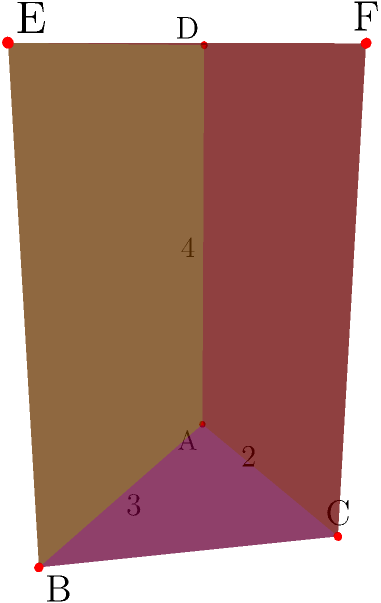As part of your daily brain exercise routine to maintain cognitive function, you're presented with a geometry challenge. Calculate the total surface area of a triangular prism with a base triangle measuring 3 units in width and 2 units in height, and a prism height of 4 units. How can you break down this problem to make it more manageable? Let's approach this step-by-step:

1) The surface area of a triangular prism consists of two triangular bases and three rectangular faces.

2) For the triangular bases:
   - Area of one triangle = $\frac{1}{2} \times base \times height$
   - Area = $\frac{1}{2} \times 3 \times 2 = 3$ square units
   - There are two identical triangular bases, so total area = $2 \times 3 = 6$ square units

3) For the rectangular faces:
   a) Rectangle ABDE:
      - Area = length × width = $3 \times 4 = 12$ square units
   b) Rectangle BCFE:
      - We need to find the hypotenuse of the base triangle using the Pythagorean theorem:
      - $hypotenuse^2 = 3^2 + 2^2 = 9 + 4 = 13$
      - $hypotenuse = \sqrt{13}$
      - Area = $\sqrt{13} \times 4 = 4\sqrt{13}$ square units
   c) Rectangle ACFD:
      - Area = $2 \times 4 = 8$ square units

4) Total surface area:
   $SA = 6 + 12 + 4\sqrt{13} + 8 = 26 + 4\sqrt{13}$ square units

By breaking down the problem into smaller, manageable parts, we've calculated the total surface area step-by-step.
Answer: $26 + 4\sqrt{13}$ square units 